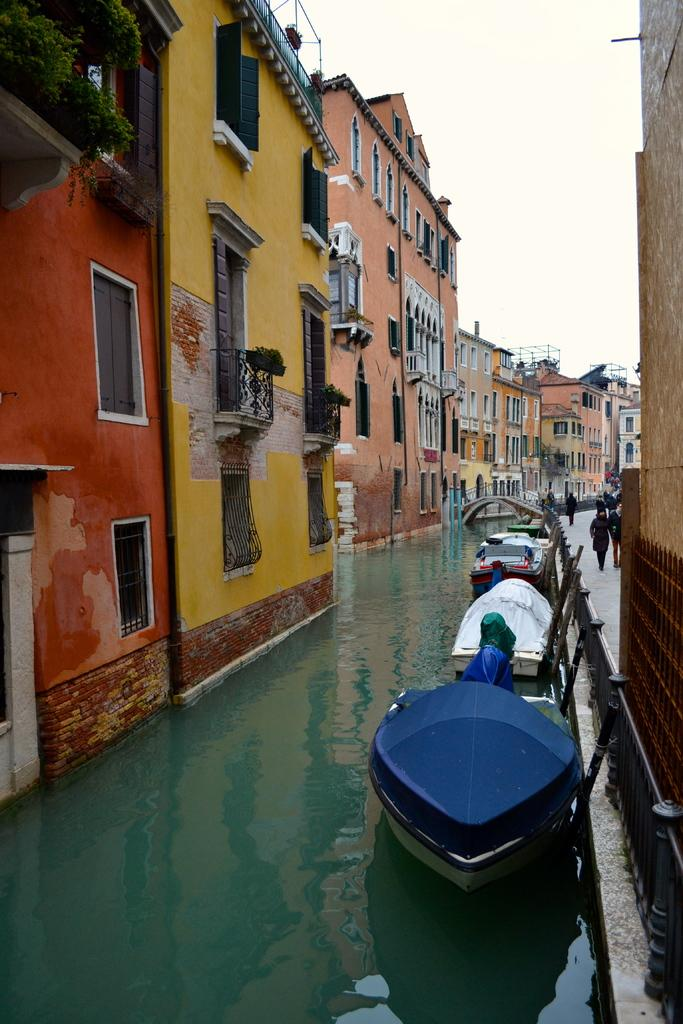What is on the water in the image? There are boats on the water in the image. What colors are the buildings in the image? The buildings in the image are in orange, yellow, and pink colors. What color are the plants in the image? The plants in the image are in green color. What color is the sky in the image? The sky appears to be in white color in the image, although it's possible that this is a transcription error and the sky is actually blue. Where is the dirt located in the image? There is no dirt present in the image. What type of nation is depicted in the image? The image does not depict a nation; it shows boats, buildings, plants, and a sky. 